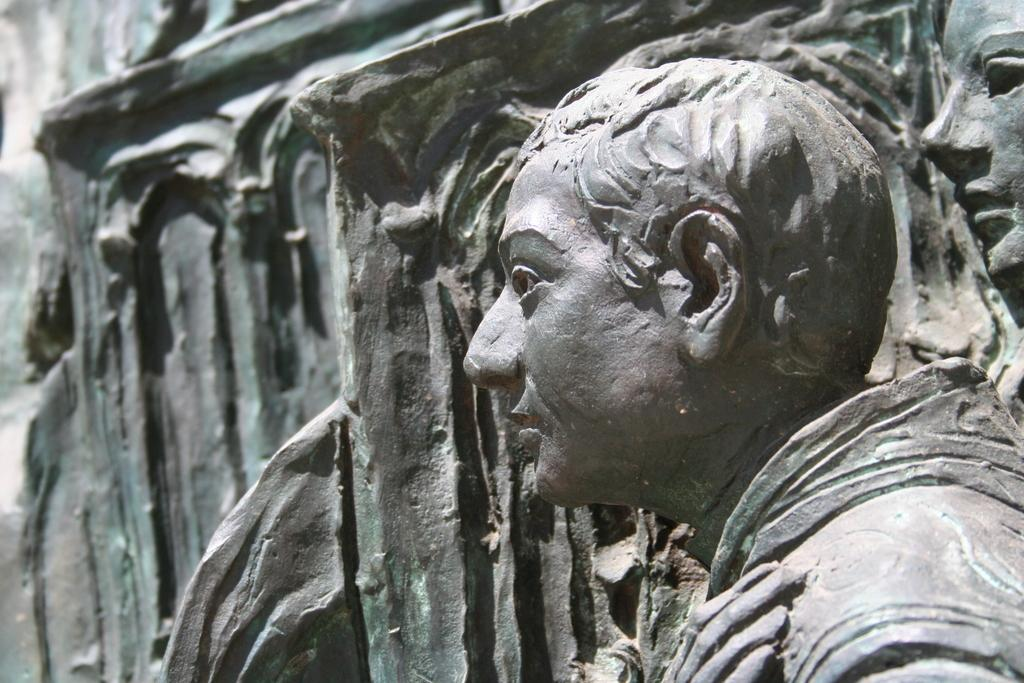What type of objects can be seen in the image? There are sculptures in the image. What type of silk fabric is being used for writing holiday cards in the image? There is no silk fabric, writing, or holiday cards present in the image; it only features sculptures. 